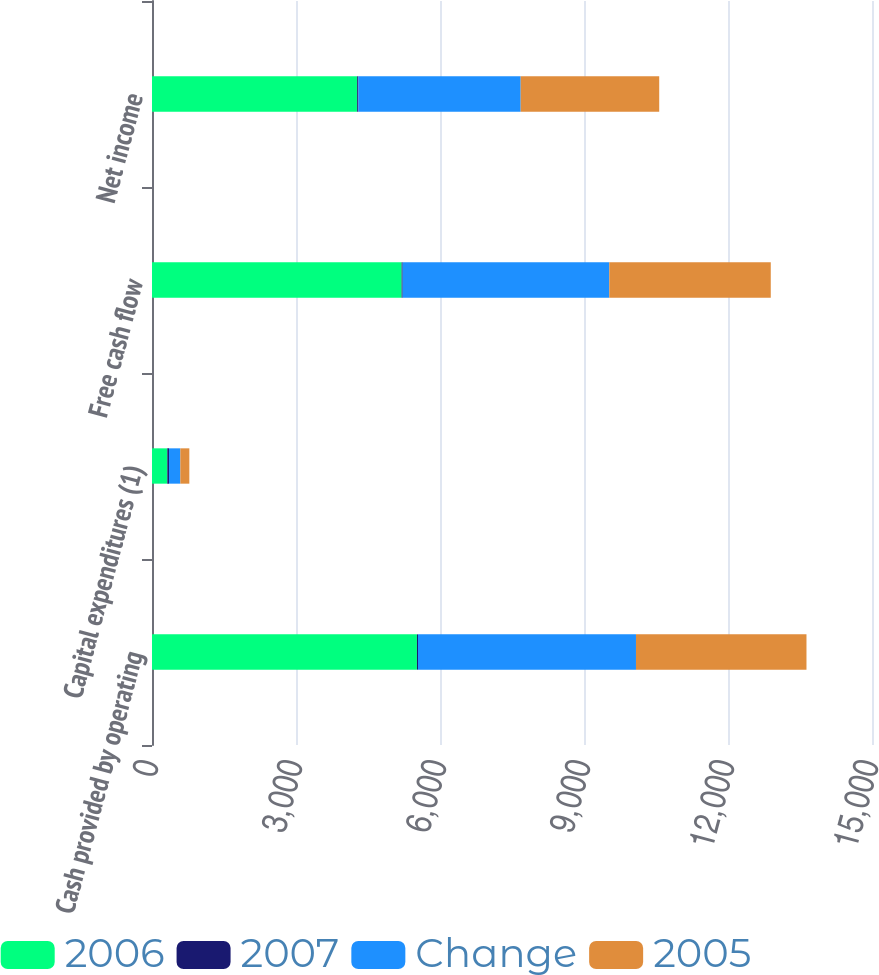<chart> <loc_0><loc_0><loc_500><loc_500><stacked_bar_chart><ecel><fcel>Cash provided by operating<fcel>Capital expenditures (1)<fcel>Free cash flow<fcel>Net income<nl><fcel>2006<fcel>5520<fcel>319<fcel>5201<fcel>4274<nl><fcel>2007<fcel>22<fcel>35<fcel>21<fcel>26<nl><fcel>Change<fcel>4541<fcel>236<fcel>4305<fcel>3381<nl><fcel>2005<fcel>3552<fcel>188<fcel>3364<fcel>2886<nl></chart> 